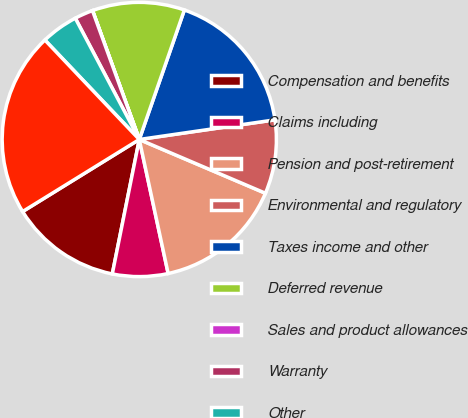Convert chart to OTSL. <chart><loc_0><loc_0><loc_500><loc_500><pie_chart><fcel>Compensation and benefits<fcel>Claims including<fcel>Pension and post-retirement<fcel>Environmental and regulatory<fcel>Taxes income and other<fcel>Deferred revenue<fcel>Sales and product allowances<fcel>Warranty<fcel>Other<fcel>Total<nl><fcel>13.04%<fcel>6.53%<fcel>15.21%<fcel>8.7%<fcel>17.38%<fcel>10.87%<fcel>0.01%<fcel>2.18%<fcel>4.36%<fcel>21.72%<nl></chart> 